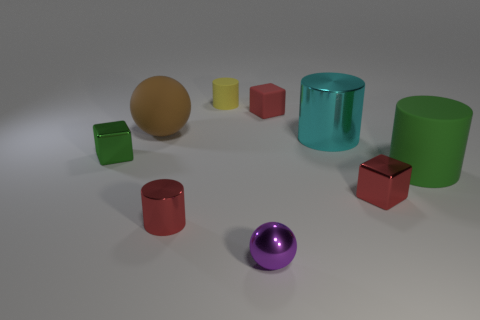There is a tiny metal object that is the same color as the big matte cylinder; what is its shape?
Provide a short and direct response. Cube. Are there an equal number of small red matte cubes on the left side of the purple ball and yellow things that are right of the small yellow thing?
Give a very brief answer. Yes. There is another object that is the same shape as the tiny purple object; what is its color?
Your answer should be compact. Brown. Is the color of the large metal cylinder the same as the rubber sphere?
Make the answer very short. No. Are the brown ball and the big green cylinder made of the same material?
Your answer should be very brief. Yes. Are there any red metal objects that have the same shape as the red rubber thing?
Provide a short and direct response. Yes. There is a matte object in front of the big metallic object; does it have the same shape as the tiny red matte object that is right of the purple metal object?
Make the answer very short. No. What is the shape of the object that is both left of the purple ball and right of the red cylinder?
Keep it short and to the point. Cylinder. Is there a metallic cube that has the same size as the brown rubber object?
Keep it short and to the point. No. There is a rubber ball; is it the same color as the metal cylinder in front of the cyan shiny thing?
Your response must be concise. No. 